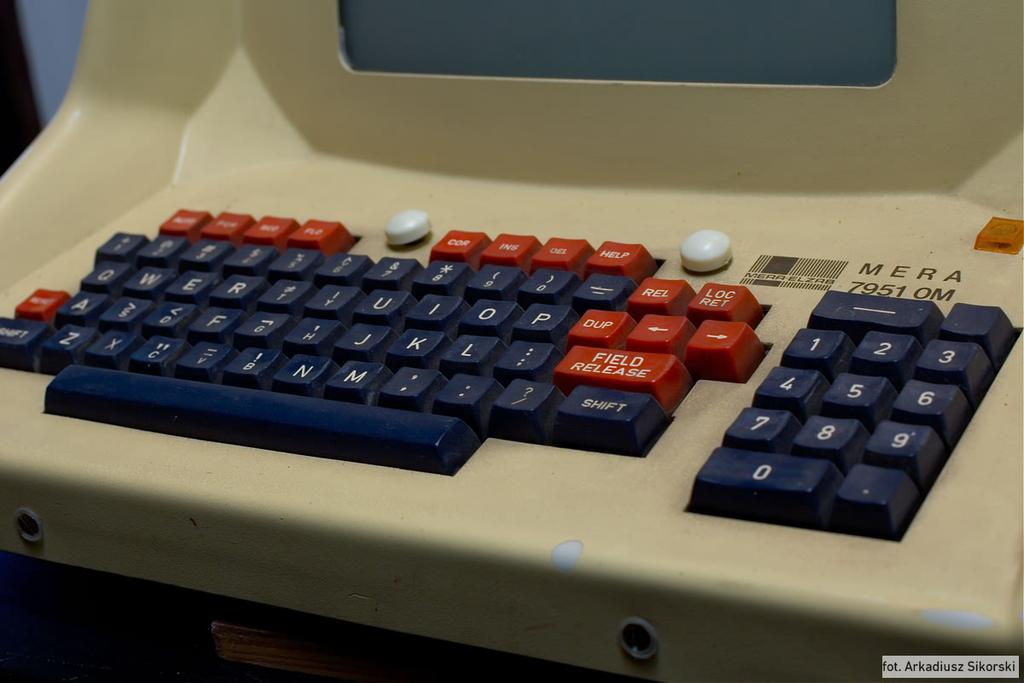<image>
Give a short and clear explanation of the subsequent image. a red key with the letters DUP on it 